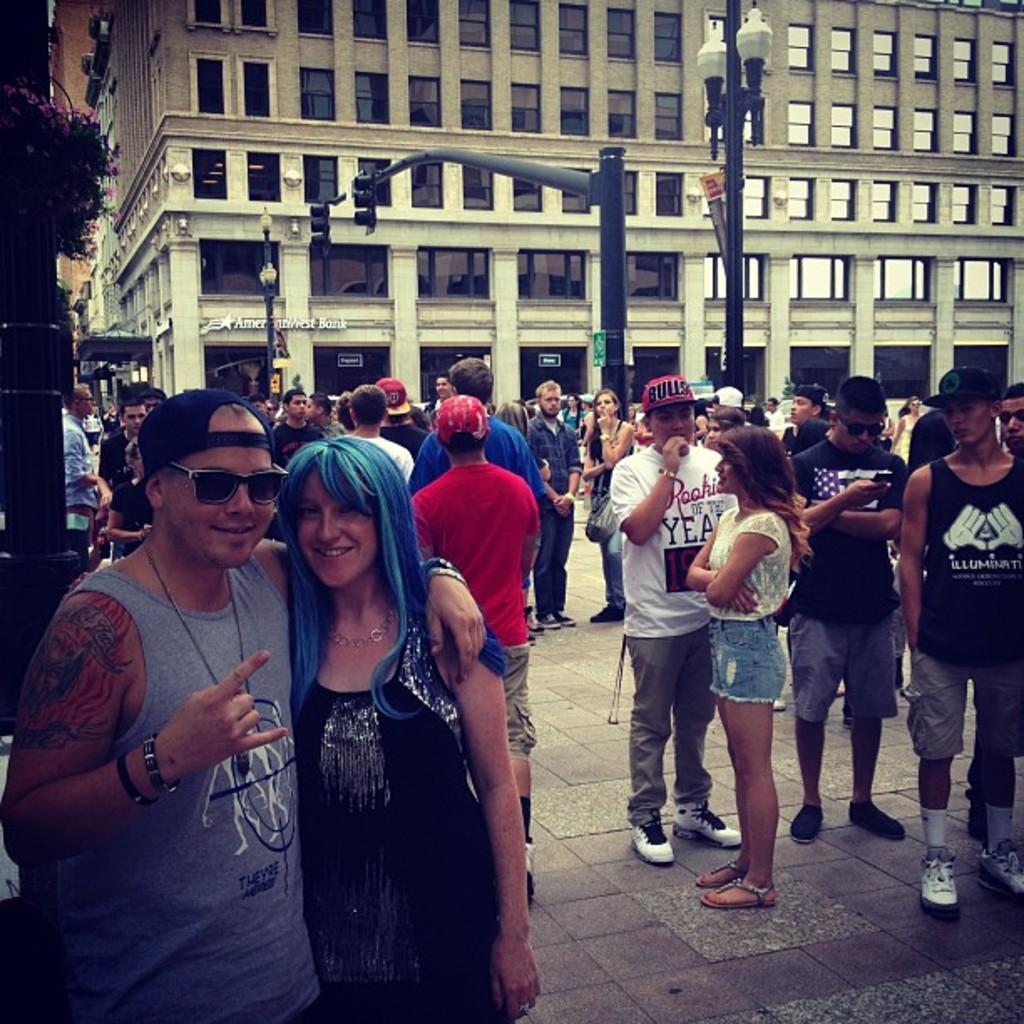How would you summarize this image in a sentence or two? In this image there are group of people standing, and in the background there are lights and signal lights attached to the poles, buildings. 